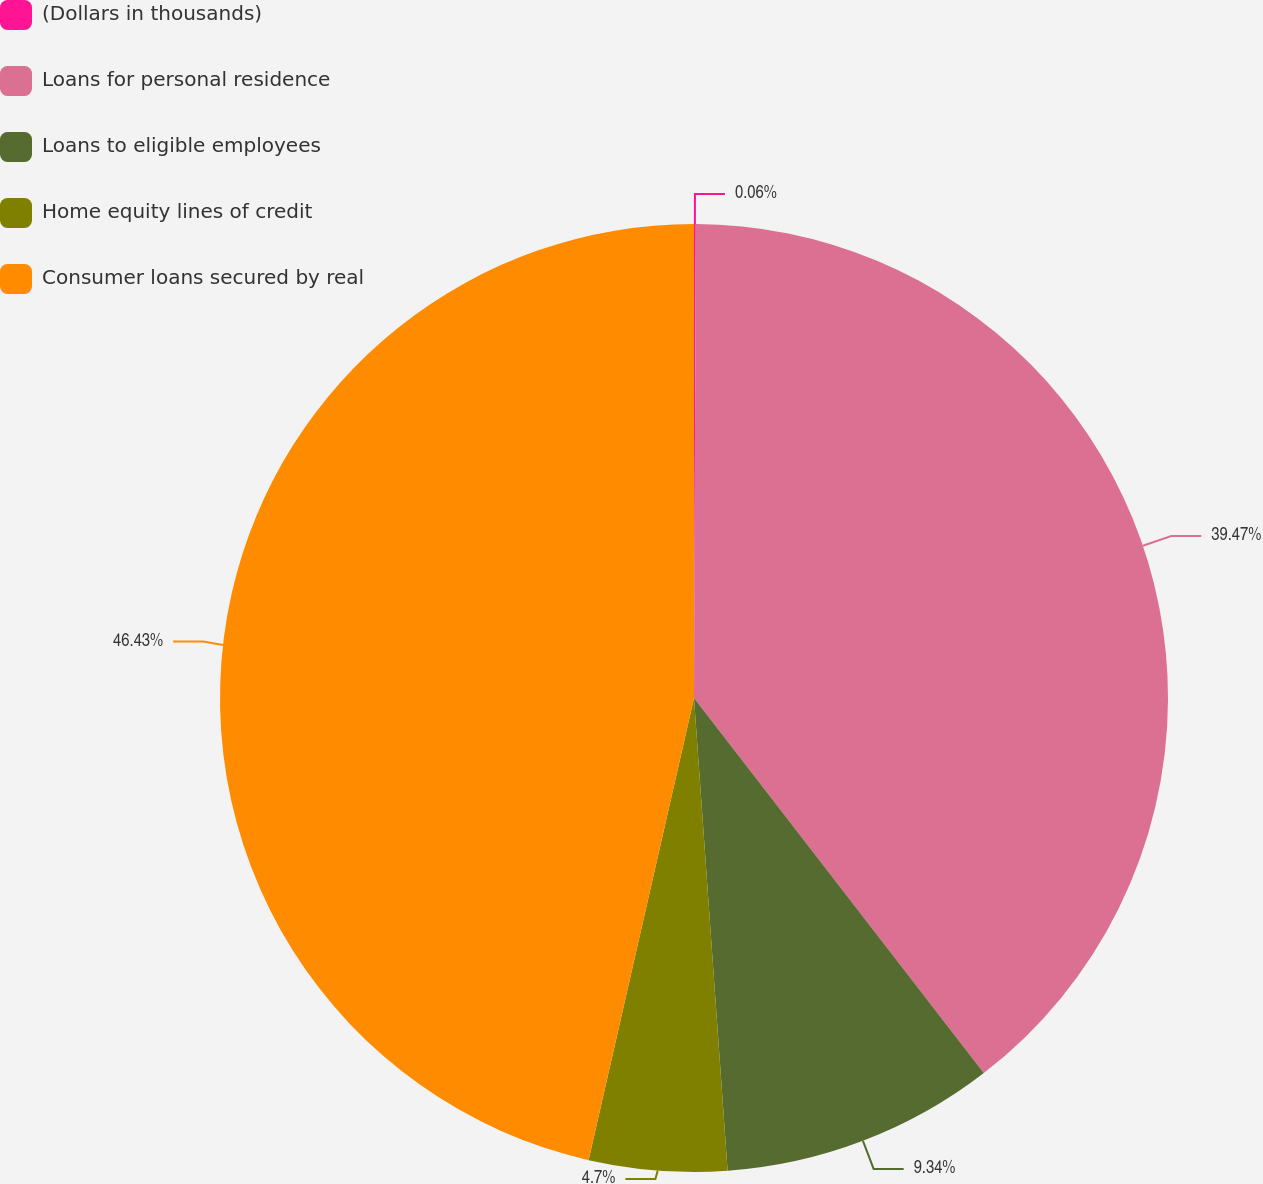Convert chart. <chart><loc_0><loc_0><loc_500><loc_500><pie_chart><fcel>(Dollars in thousands)<fcel>Loans for personal residence<fcel>Loans to eligible employees<fcel>Home equity lines of credit<fcel>Consumer loans secured by real<nl><fcel>0.06%<fcel>39.47%<fcel>9.34%<fcel>4.7%<fcel>46.43%<nl></chart> 